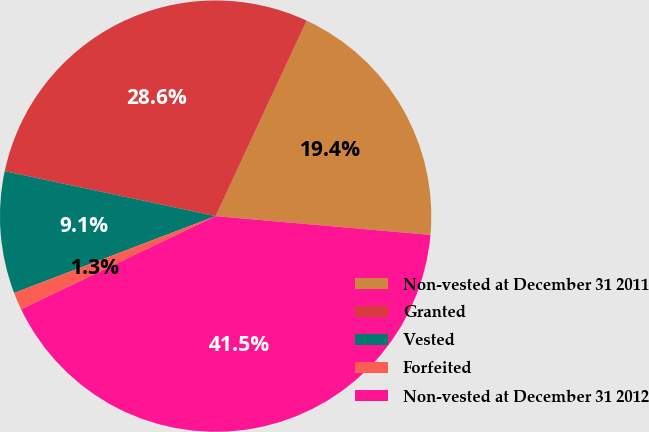Convert chart. <chart><loc_0><loc_0><loc_500><loc_500><pie_chart><fcel>Non-vested at December 31 2011<fcel>Granted<fcel>Vested<fcel>Forfeited<fcel>Non-vested at December 31 2012<nl><fcel>19.45%<fcel>28.6%<fcel>9.14%<fcel>1.31%<fcel>41.51%<nl></chart> 